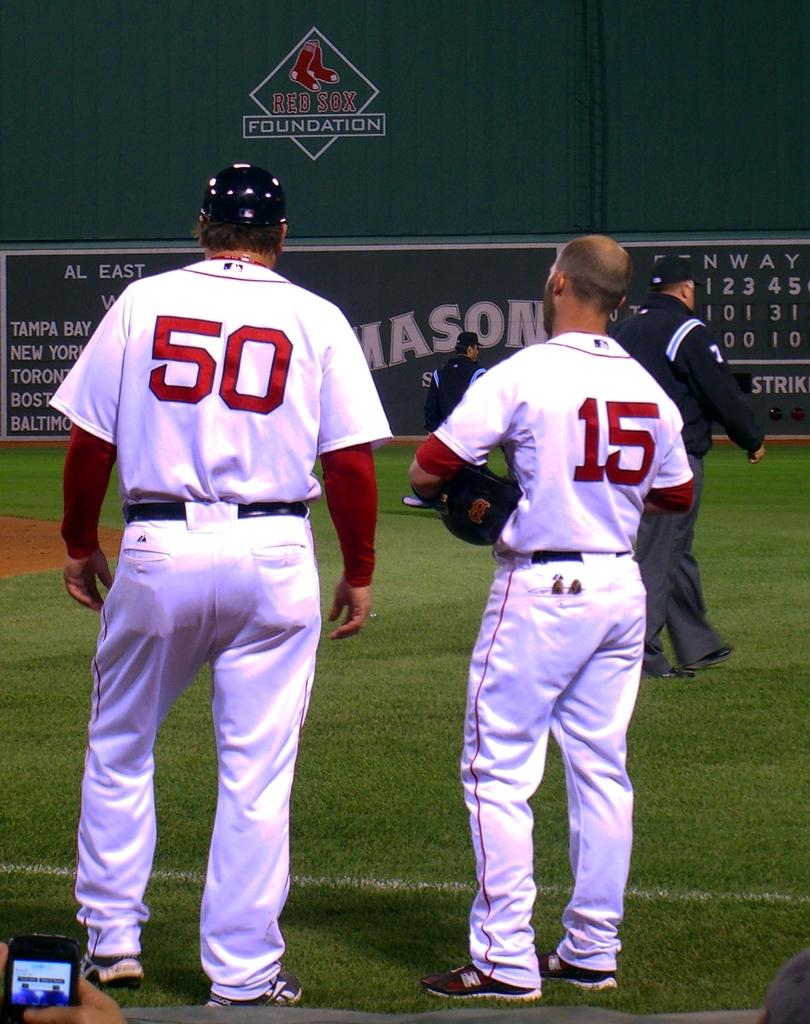What is the color of the team uniform?
Give a very brief answer. Answering does not require reading text in the image. 